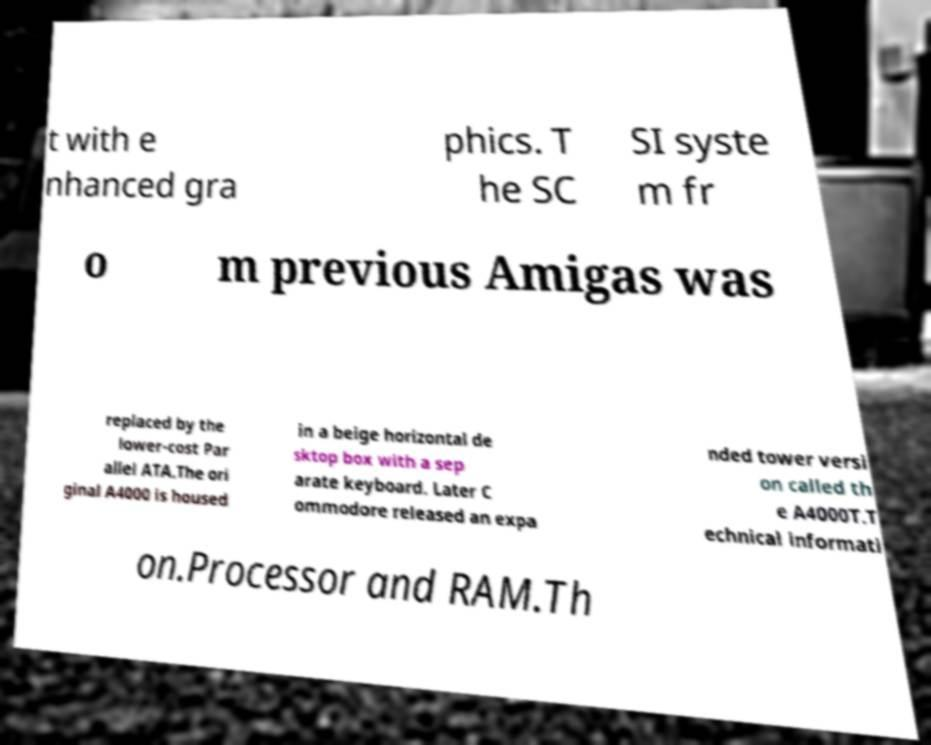Please read and relay the text visible in this image. What does it say? t with e nhanced gra phics. T he SC SI syste m fr o m previous Amigas was replaced by the lower-cost Par allel ATA.The ori ginal A4000 is housed in a beige horizontal de sktop box with a sep arate keyboard. Later C ommodore released an expa nded tower versi on called th e A4000T.T echnical informati on.Processor and RAM.Th 